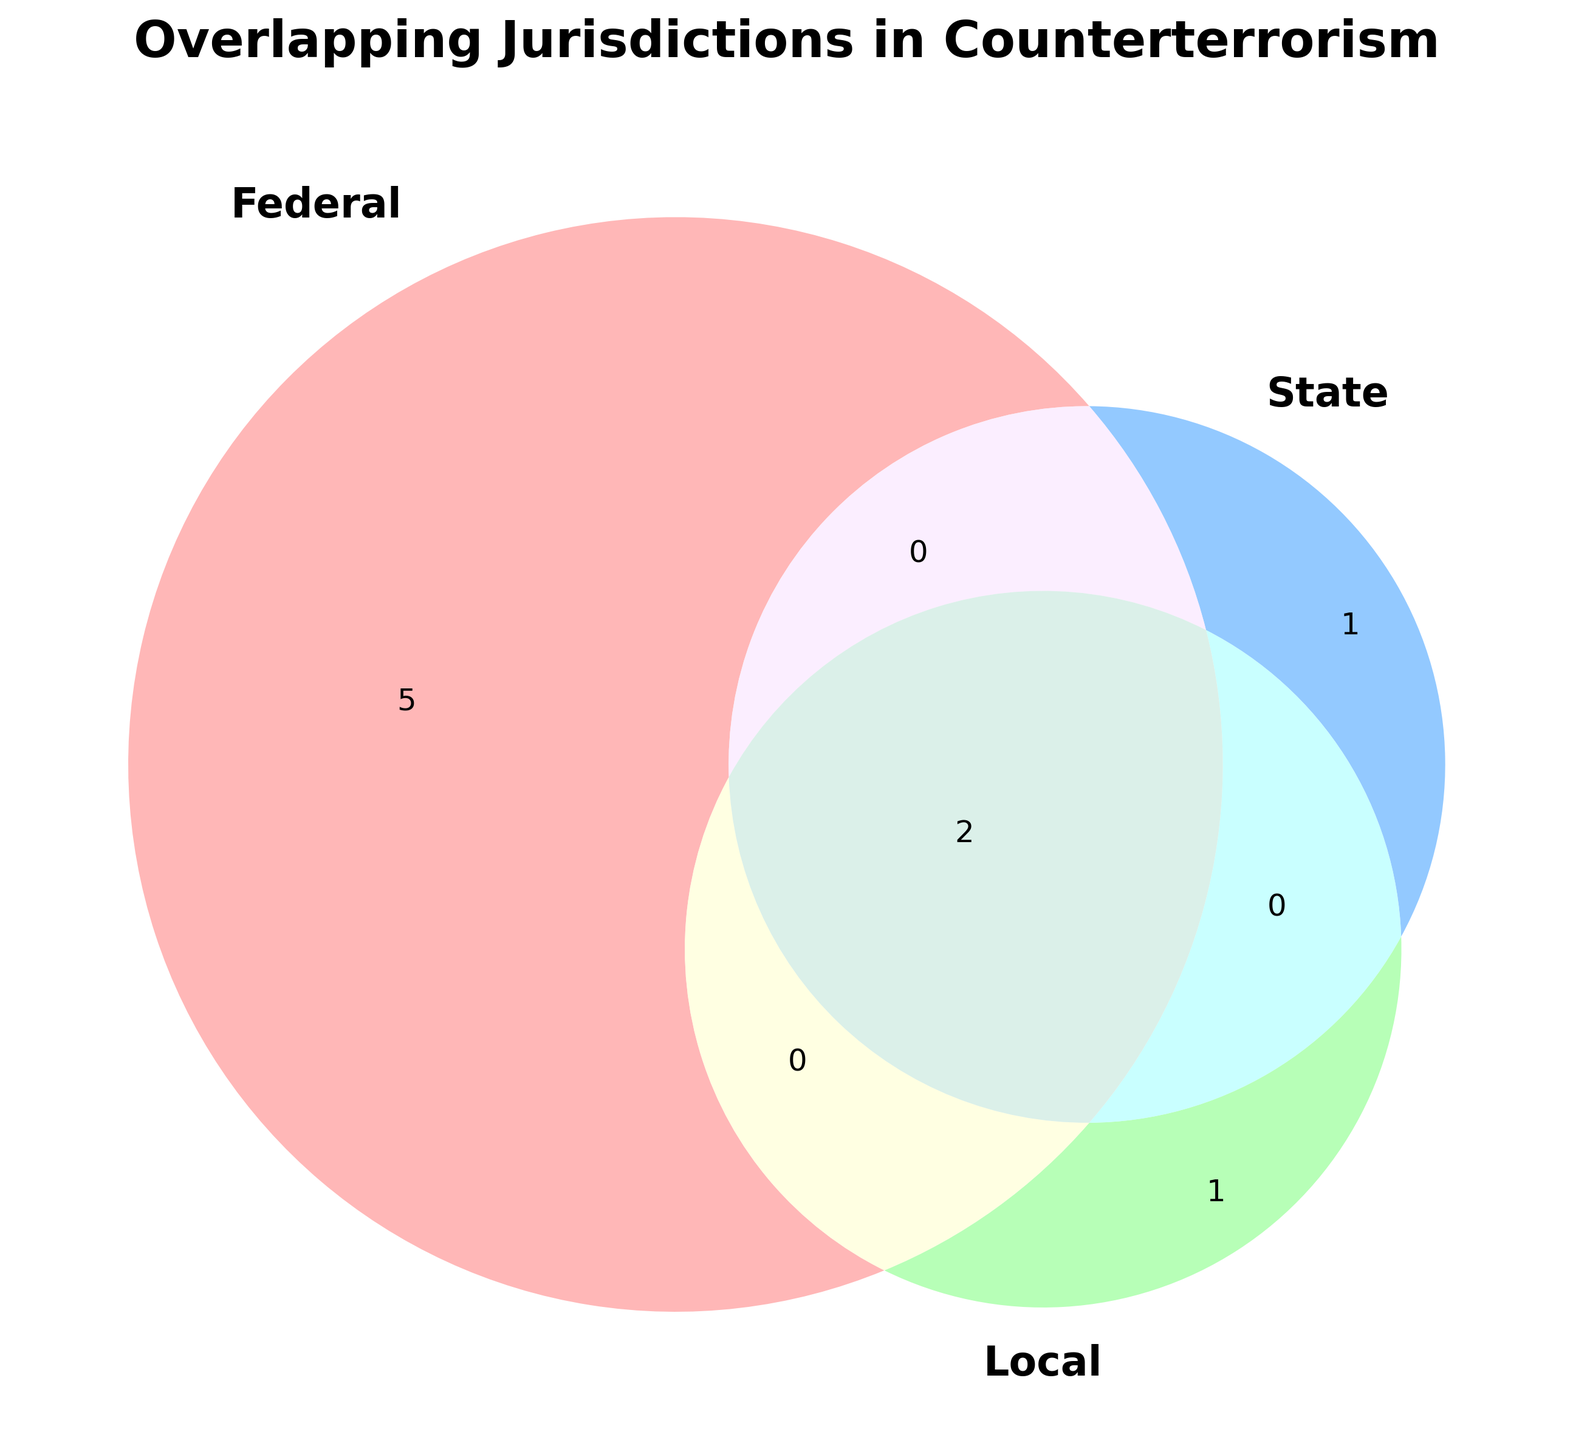What is the title of the figure? The title is usually found at the top of the figure and provides a summary of what the figure is about.
Answer: Overlapping Jurisdictions in Counterterrorism Which agency has the most overlapping jurisdictions? By looking at the figure, find the agency that appears in the most overlap areas (intersection of circles) representing Federal, State, and Local.
Answer: Joint Terrorism Task Force How many agencies have federal jurisdiction? Count the number of agencies listed in the 'Federal' circle or overlapping with it.
Answer: 7 Do any agencies have jurisdiction that covers both State and International? Look for intersections between the 'State' and 'International' areas in the figure.
Answer: No Which agency is indicated by the intersection of Federal and State but not Local? Identify the agencies in the overlap of Federal and State circles, excluding Local.
Answer: State Police, Customs and Border Protection Which jurisdictions does the DHS cover? Look at where 'DHS' is placed on the Venn Diagram to see which circles it overlaps with.
Answer: Federal, State, Local Are there any agencies that only have Local jurisdiction? Look for agencies that are only within the 'Local' circle and not overlapping with any other.
Answer: Local Police How many agencies operate solely under Federal jurisdiction without any State or Local overlap? Count the agencies in the Federal circle that do not intersect with State or Local.
Answer: 3 Which agency operates in both International and Federal jurisdictions but is not involved in State or Local? Find the agency in the overlapping area of International and Federal without State or Local.
Answer: Interpol Is there any agency involved in only International operations? Look for agencies within the International area that do not overlap with Federal, State, or Local.
Answer: Europol 